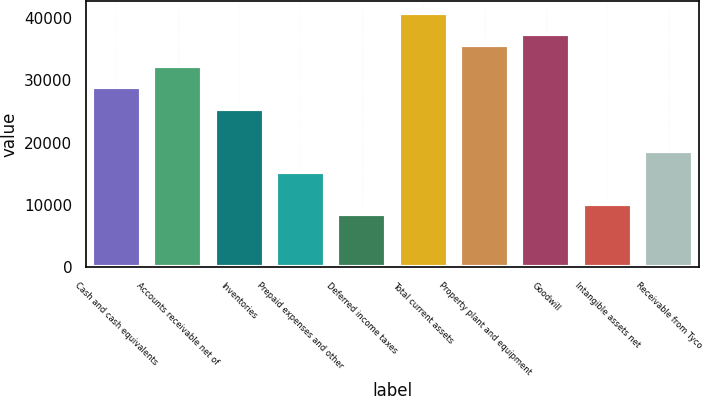Convert chart to OTSL. <chart><loc_0><loc_0><loc_500><loc_500><bar_chart><fcel>Cash and cash equivalents<fcel>Accounts receivable net of<fcel>Inventories<fcel>Prepaid expenses and other<fcel>Deferred income taxes<fcel>Total current assets<fcel>Property plant and equipment<fcel>Goodwill<fcel>Intangible assets net<fcel>Receivable from Tyco<nl><fcel>28880.8<fcel>32277.6<fcel>25484<fcel>15293.6<fcel>8500<fcel>40769.6<fcel>35674.4<fcel>37372.8<fcel>10198.4<fcel>18690.4<nl></chart> 